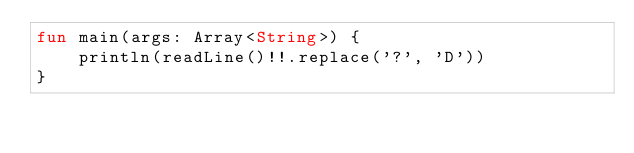<code> <loc_0><loc_0><loc_500><loc_500><_Kotlin_>fun main(args: Array<String>) {
    println(readLine()!!.replace('?', 'D'))
}</code> 